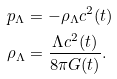Convert formula to latex. <formula><loc_0><loc_0><loc_500><loc_500>p _ { \Lambda } & = - \rho _ { \Lambda } c ^ { 2 } ( t ) \\ \rho _ { \Lambda } & = \frac { \Lambda c ^ { 2 } ( t ) } { 8 \pi G ( t ) } .</formula> 